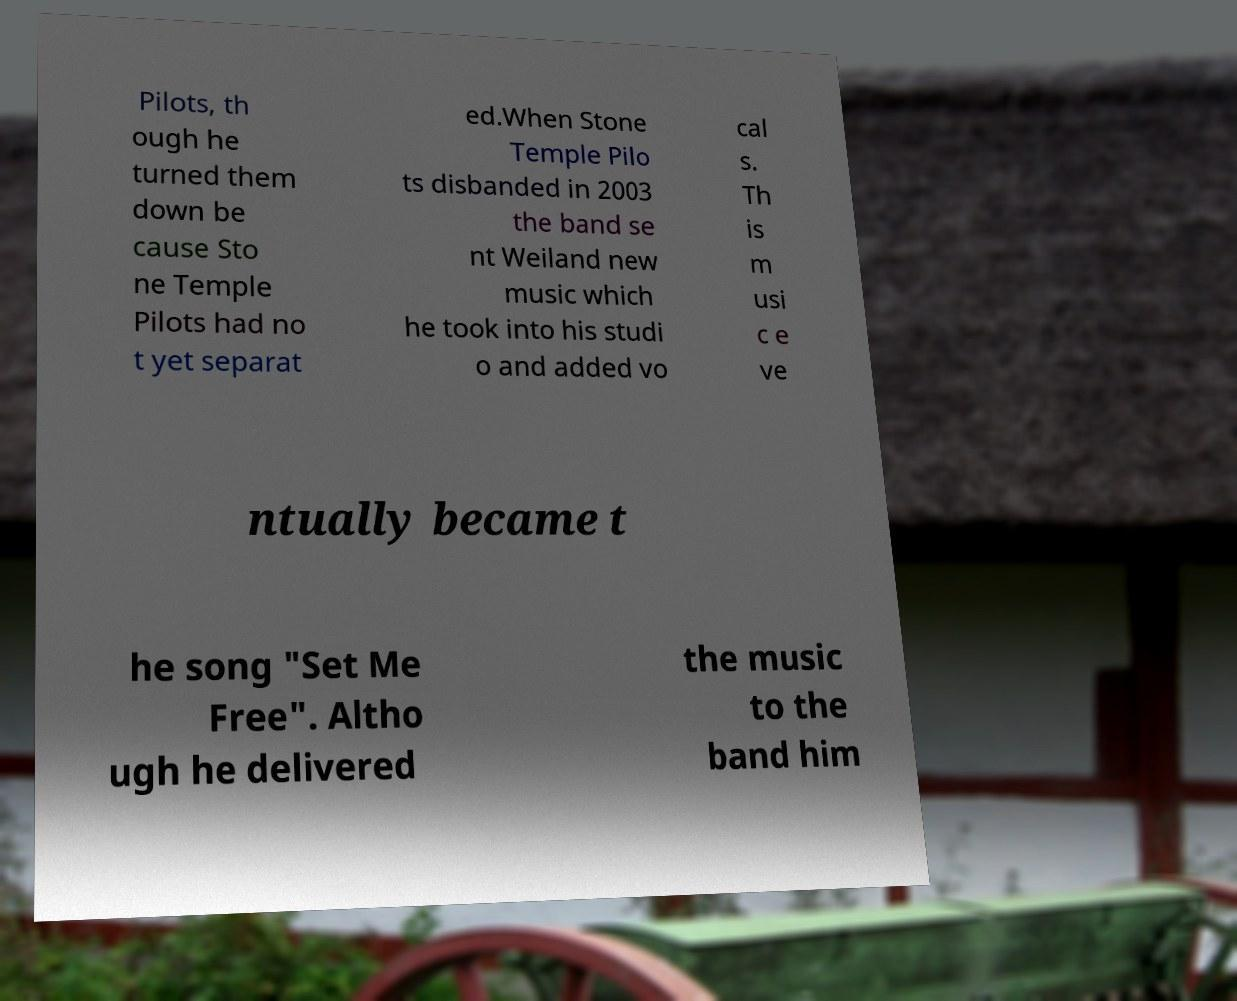Could you extract and type out the text from this image? Pilots, th ough he turned them down be cause Sto ne Temple Pilots had no t yet separat ed.When Stone Temple Pilo ts disbanded in 2003 the band se nt Weiland new music which he took into his studi o and added vo cal s. Th is m usi c e ve ntually became t he song "Set Me Free". Altho ugh he delivered the music to the band him 